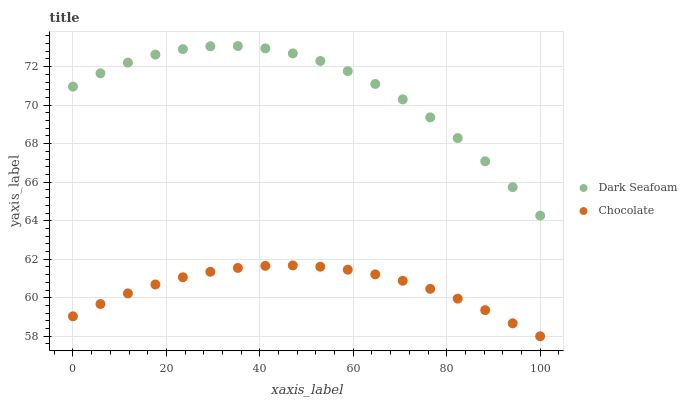Does Chocolate have the minimum area under the curve?
Answer yes or no. Yes. Does Dark Seafoam have the maximum area under the curve?
Answer yes or no. Yes. Does Chocolate have the maximum area under the curve?
Answer yes or no. No. Is Chocolate the smoothest?
Answer yes or no. Yes. Is Dark Seafoam the roughest?
Answer yes or no. Yes. Is Chocolate the roughest?
Answer yes or no. No. Does Chocolate have the lowest value?
Answer yes or no. Yes. Does Dark Seafoam have the highest value?
Answer yes or no. Yes. Does Chocolate have the highest value?
Answer yes or no. No. Is Chocolate less than Dark Seafoam?
Answer yes or no. Yes. Is Dark Seafoam greater than Chocolate?
Answer yes or no. Yes. Does Chocolate intersect Dark Seafoam?
Answer yes or no. No. 